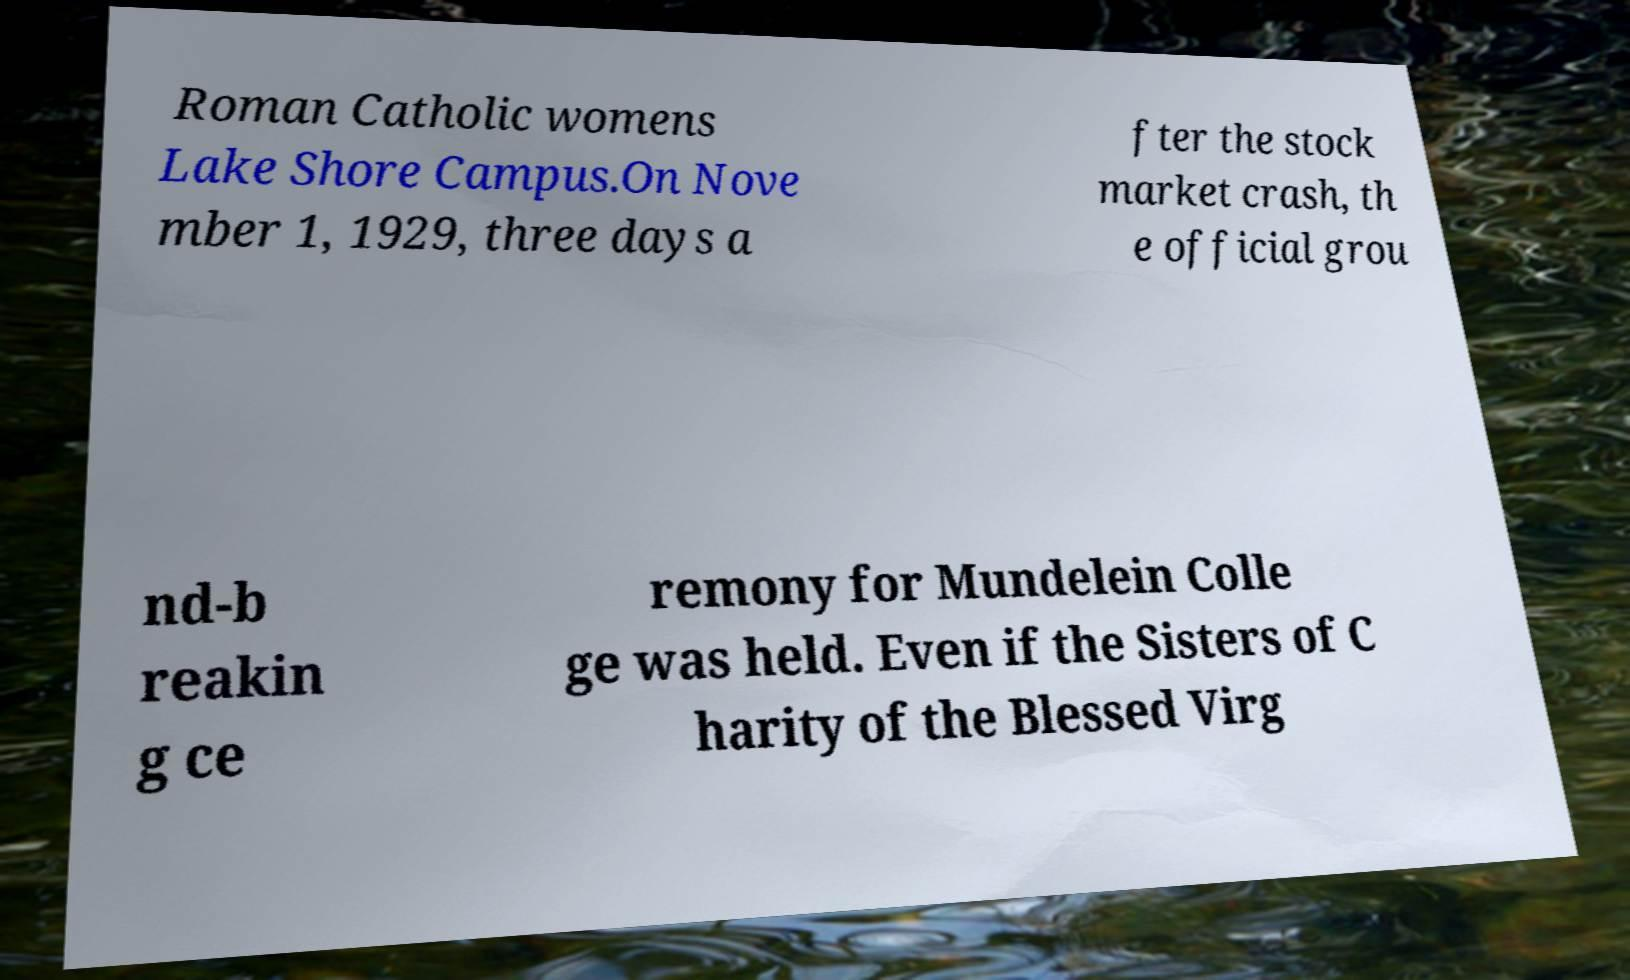Please read and relay the text visible in this image. What does it say? Roman Catholic womens Lake Shore Campus.On Nove mber 1, 1929, three days a fter the stock market crash, th e official grou nd-b reakin g ce remony for Mundelein Colle ge was held. Even if the Sisters of C harity of the Blessed Virg 